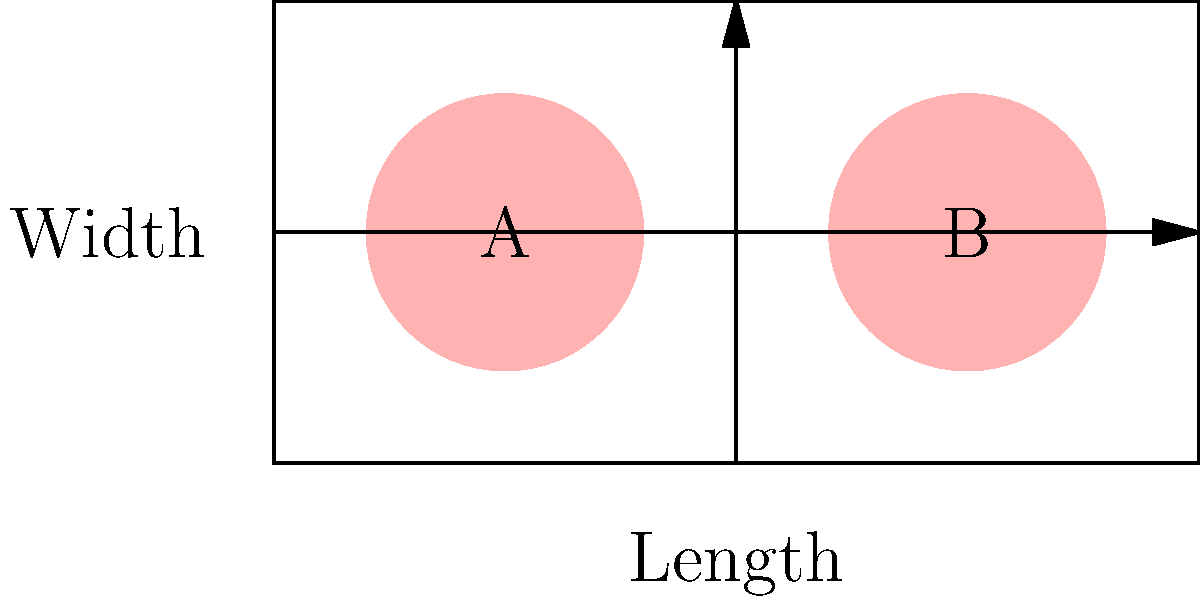Consider the topological representation of a sports field with two high-risk concussion zones (A and B) shown above. If these zones were to be connected by a path that doesn't intersect the field boundaries, what would be the genus of the resulting surface? To determine the genus of the resulting surface, we need to follow these steps:

1. Understand the initial topology:
   - The sports field is initially a simple rectangle, topologically equivalent to a disk (genus 0).
   - The two high-risk zones (A and B) are also topologically equivalent to disks.

2. Connecting the zones:
   - If we connect zones A and B with a path that doesn't intersect the field boundaries, we're essentially creating a "handle" on the surface.

3. Topological transformation:
   - This transformation is equivalent to cutting out the two circular zones and connecting them with a tube (the path).
   - In topological terms, this operation is called adding a "handle" to the surface.

4. Calculating the genus:
   - The genus of a surface is the number of handles it has.
   - Initially, our surface (the rectangular field) had genus 0.
   - By adding one handle to connect the two zones, we increase the genus by 1.

5. Final result:
   - The resulting surface after connecting the two zones will have a genus of 1.

This topological transformation is similar to how a coffee cup (with one handle) is topologically equivalent to a donut (torus), both having a genus of 1.
Answer: 1 